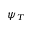<formula> <loc_0><loc_0><loc_500><loc_500>\psi _ { T }</formula> 